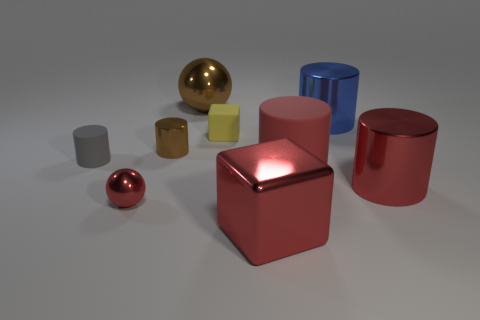What is the shape of the gray rubber thing?
Your response must be concise. Cylinder. What number of other things are made of the same material as the big brown object?
Make the answer very short. 5. What is the color of the big metallic object that is left of the large object in front of the ball in front of the brown metallic ball?
Offer a very short reply. Brown. There is a red sphere that is the same size as the gray object; what material is it?
Your answer should be compact. Metal. How many objects are either large red matte cylinders on the right side of the gray cylinder or large objects?
Your answer should be compact. 5. Are any big purple balls visible?
Offer a very short reply. No. What is the material of the brown object in front of the small yellow rubber cube?
Offer a terse response. Metal. How many small things are red matte things or brown things?
Ensure brevity in your answer.  1. The big matte object has what color?
Give a very brief answer. Red. There is a red metal thing to the left of the small block; are there any large red objects that are in front of it?
Offer a very short reply. Yes. 